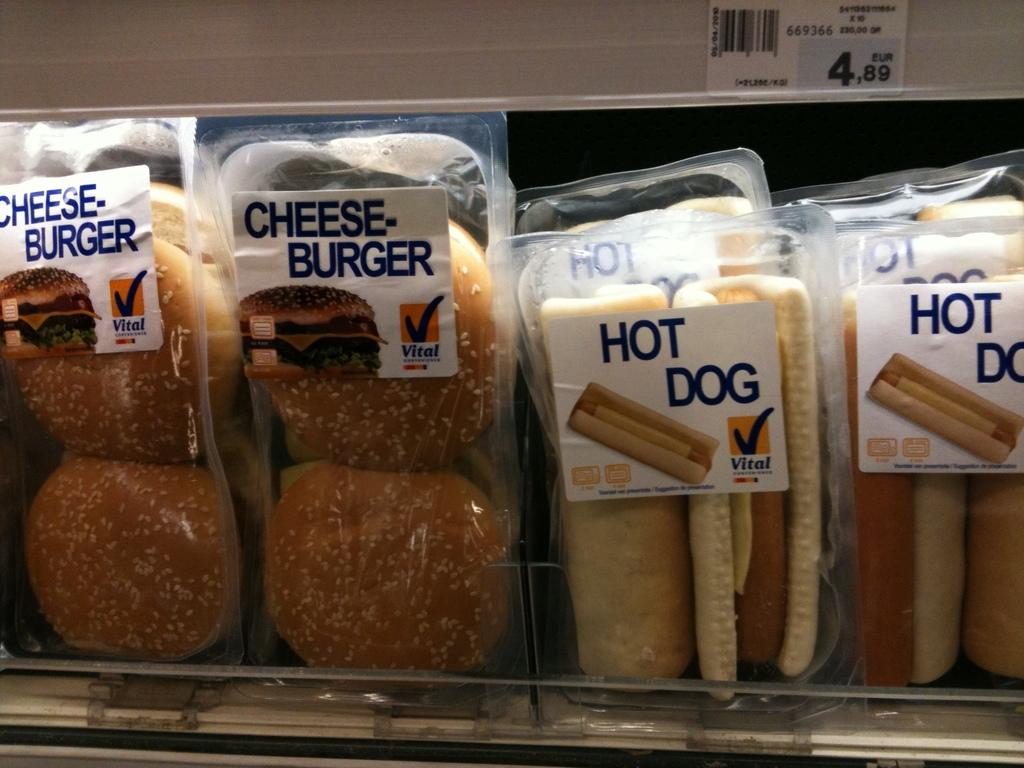What type of food is depicted in the image? The image contains hot dog boxes and cheeseburger boxes. How many hot dog boxes are present in the image? There are two hot dog boxes in the image. How many cheeseburger boxes are present in the image? There are two cheeseburger boxes in the image. What type of learning material is visible in the image? There is no learning material present in the image; it only contains hot dog and cheeseburger boxes. Are any masks visible in the image? There are no masks present in the image. 